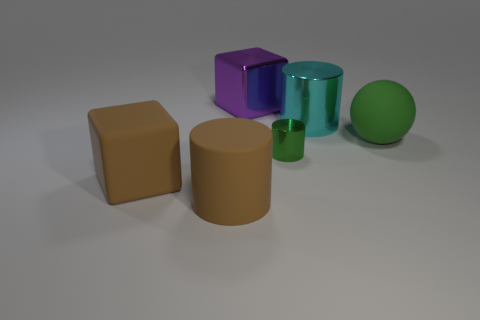Are there any objects that stand out due to their size? Yes, the golden-brown cube on the left appears to be the largest object in terms of volume, making it stand out in the group of objects. Does the size of an object affect its appearance in other ways? Certainly. The size of an object can affect the perception of its color and texture due to the amount of surface area reflecting light, and it can also influence how it interacts with shadows and highlights within a scene, contributing to the image's overall composition. 